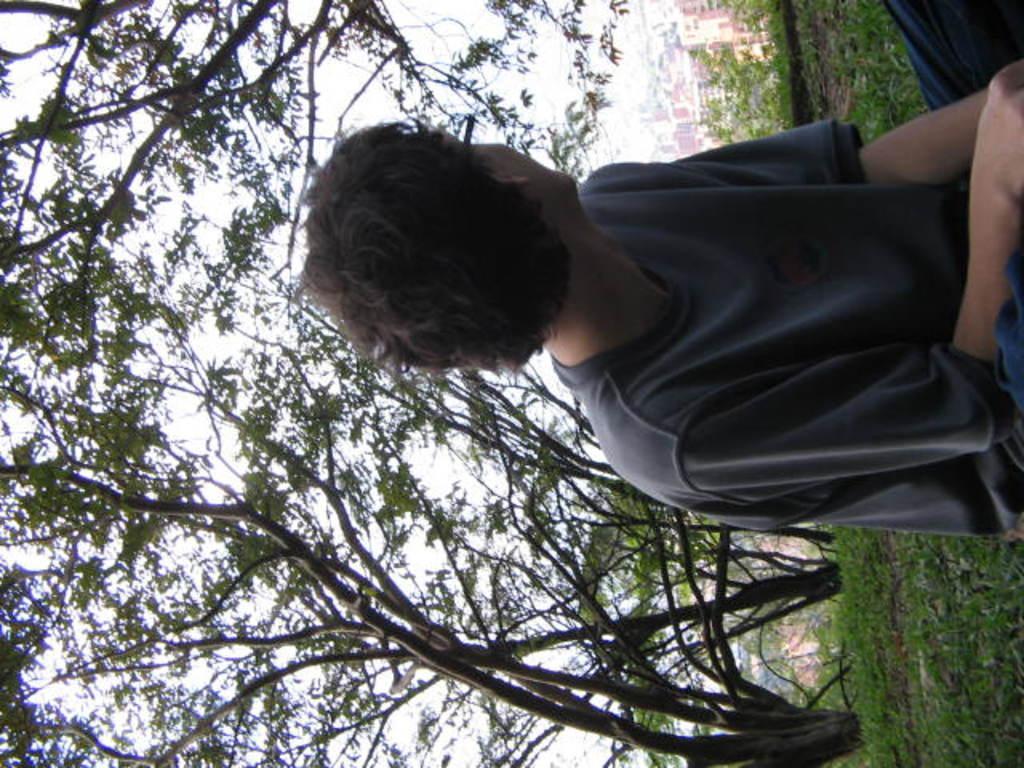How would you summarize this image in a sentence or two? In this image there is a person sitting on the ground and there is grass on the ground and in the background there are buildings and trees and the sky is cloudy. 